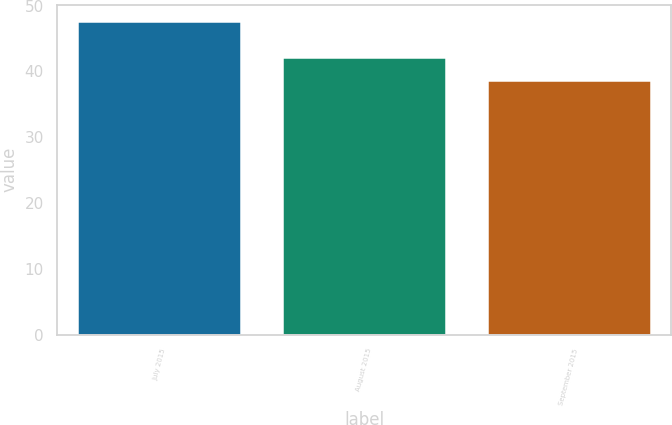Convert chart. <chart><loc_0><loc_0><loc_500><loc_500><bar_chart><fcel>July 2015<fcel>August 2015<fcel>September 2015<nl><fcel>47.71<fcel>42.21<fcel>38.66<nl></chart> 